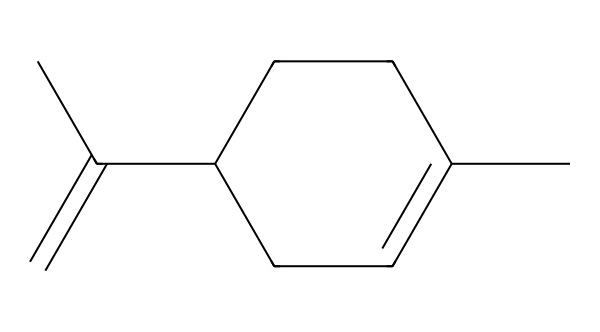What is the molecular formula of limonene? To determine the molecular formula, count the number of carbon (C) and hydrogen (H) atoms in the structure represented by the SMILES. The structure shows 10 carbons and 16 hydrogens.
Answer: C10H16 How many chiral centers are present in limonene? A chiral center is indicated by a carbon atom that has four different substituents. In the limonene structure, there is one such carbon atom with different groups attached.
Answer: 1 What type of isomerism does limonene exhibit? Limonene can exist in two mirror-image forms (enantiomers) due to its chiral center. This leads to the characteristic of optical isomerism.
Answer: optical isomerism Which functional groups are present in limonene? Limonene is a terpene, which primarily consists of a hydrocarbon structure. It does not have traditional functional groups like alcohols or acids but has a double bond, contributing to its reactivity.
Answer: terpenes What is the possible use of limonene in cleaning products? The presence of a non-polar hydrocarbon and the pleasant citrus scent make limonene an effective degreaser and fragrance agent in cleaning products.
Answer: degreaser Does limonene have any notable odor? Limonene is well known for its citrus scent, characteristic of the oils found in citrus fruits. This pleasant aroma makes it popular in various products.
Answer: citrus scent 